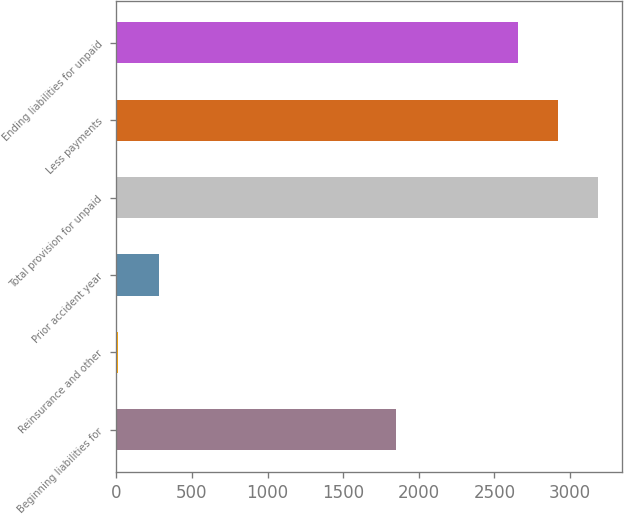Convert chart to OTSL. <chart><loc_0><loc_0><loc_500><loc_500><bar_chart><fcel>Beginning liabilities for<fcel>Reinsurance and other<fcel>Prior accident year<fcel>Total provision for unpaid<fcel>Less payments<fcel>Ending liabilities for unpaid<nl><fcel>1851<fcel>13<fcel>280.1<fcel>3186.5<fcel>2919.4<fcel>2652.3<nl></chart> 